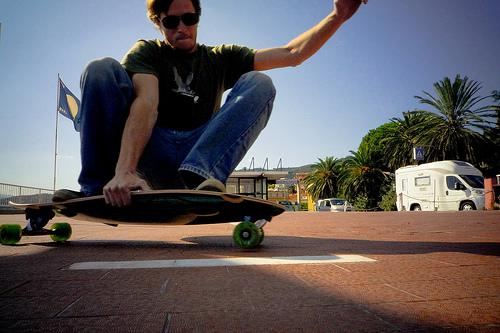Question: where is this scene?
Choices:
A. At the school.
B. At the store.
C. At the church.
D. At a park.
Answer with the letter. Answer: D Question: who is this?
Choices:
A. A child.
B. A baby.
C. Man.
D. A woman.
Answer with the letter. Answer: C Question: what is cast?
Choices:
A. Fishing line.
B. Shadow.
C. Actor.
D. Play.
Answer with the letter. Answer: B Question: why is he on the board?
Choices:
A. Waiting.
B. Surfing.
C. Looking.
D. Riding.
Answer with the letter. Answer: D 